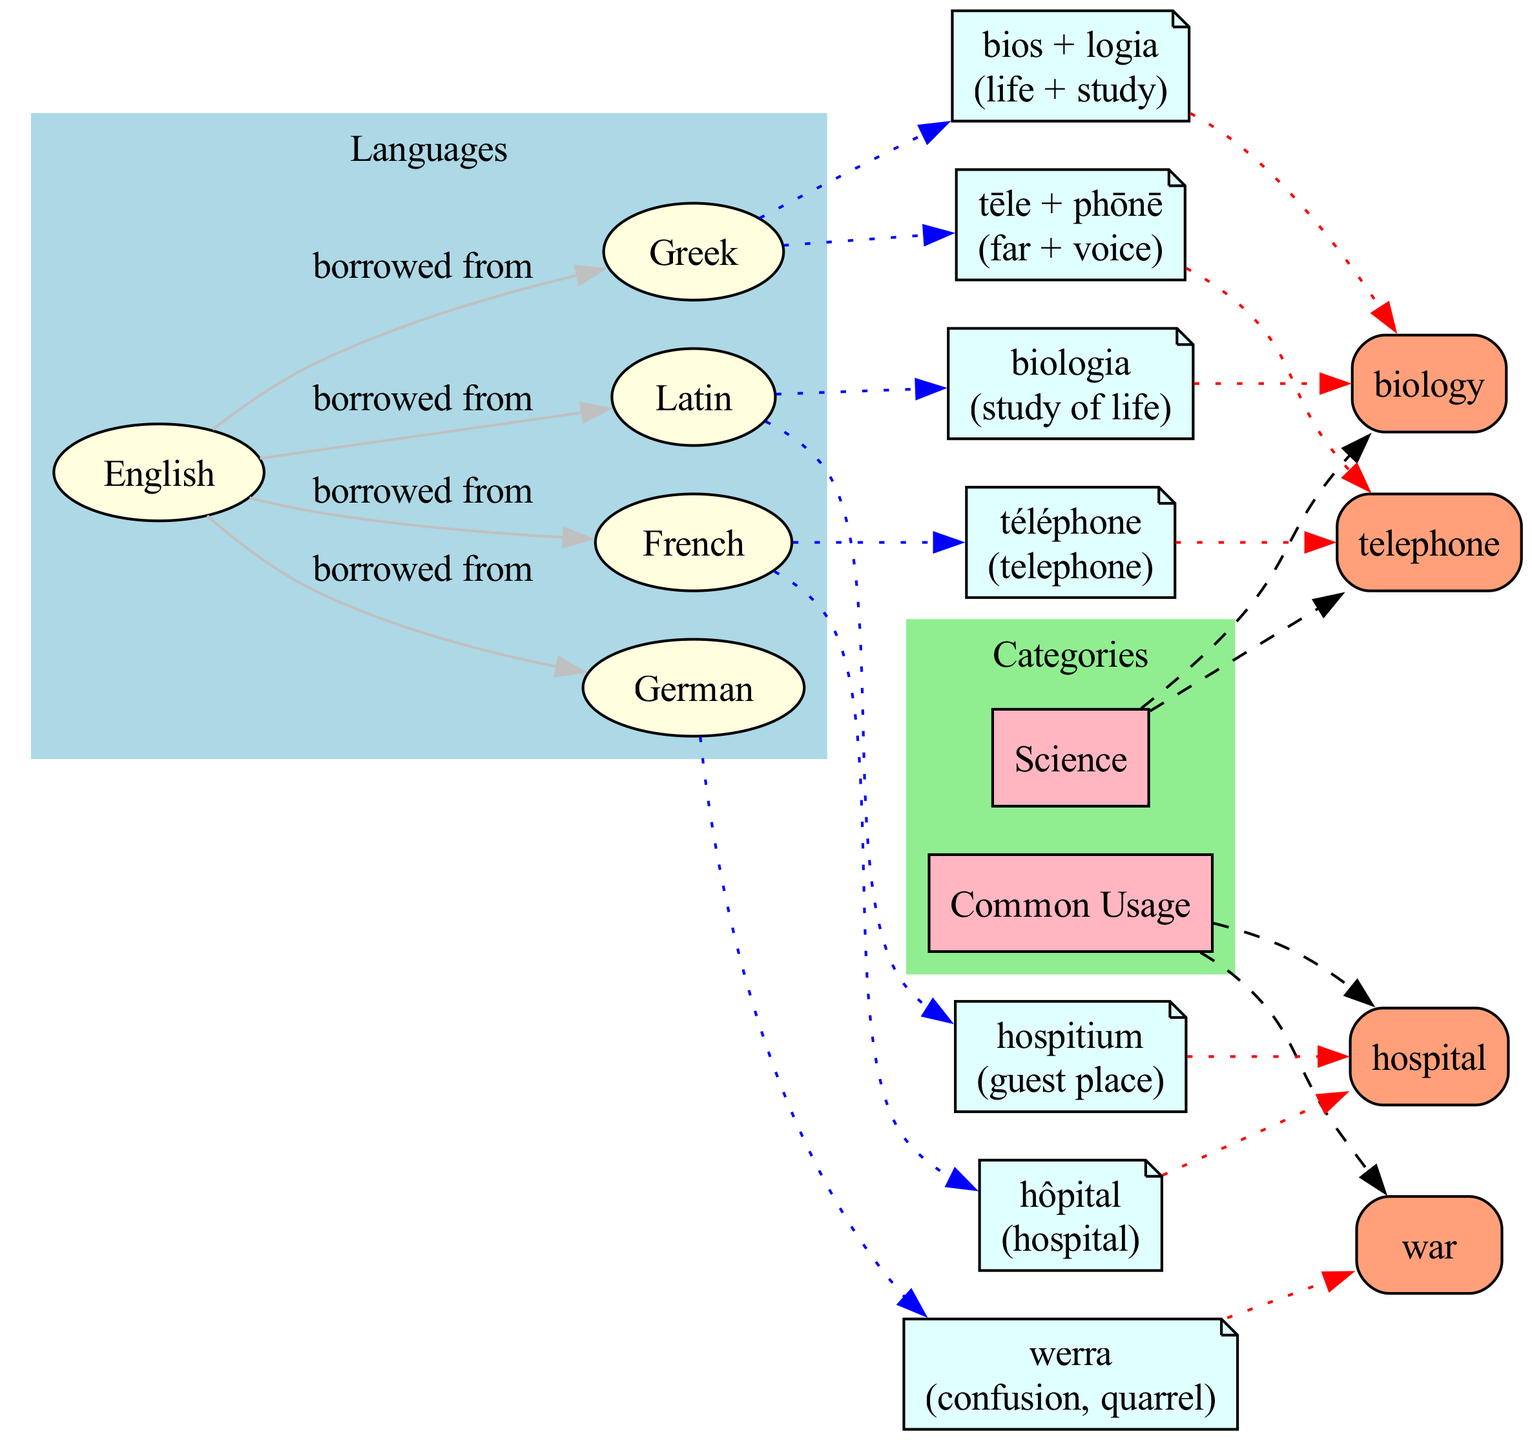What is the origin of the word "biology"? The diagram shows that "biology" has etymological roots in both Latin and Greek. The specific origin from Latin is listed as "biologia," while from Greek it is "bios + logia."
Answer: biologia How many languages are represented in this diagram? The diagram lists five languages: English, Latin, French, German, and Greek. By counting the nodes labeled as languages, we find a total of five.
Answer: 5 What does "hospital" mean in Latin? According to the etymology provided in the diagram, the Latin origin of "hospital" is "hospitium," which means "guest place."
Answer: guest place Which language contributed the etymology for the word "war"? The diagram indicates that the etymology for "war" comes exclusively from German, where the term is "werra." Therefore, it does not have roots from any other languages.
Answer: German How many words are categorized under 'science'? The diagram displays two words that fall under the 'science' category: "biology" and "telephone." By counting the boxes connected to the 'science' node, we confirm there are two words.
Answer: 2 What is the meaning of "telephone" in Greek? The etymology section for "telephone" in the diagram shows its Greek origin as "tēle + phōnē," which translates to "far + voice."
Answer: far + voice Which word has etymological roots in French and Latin? From the diagram, "hospital" is linked to both Latin ("hospitium") and French ("hôpital"). Hence, it is the only word indicated to have etymological roots in both languages.
Answer: hospital What is the main category that includes "war"? The diagram categorizes "war" under the common usage category. By tracing the connections, we see it linked to this specific category, making it clear where it belongs.
Answer: common usage How many edges connect English to other languages? The diagram details four edges that connect English to its borrowed languages: Latin, French, German, and Greek. After examining the edges, we count a total of four connections emanating from English.
Answer: 4 